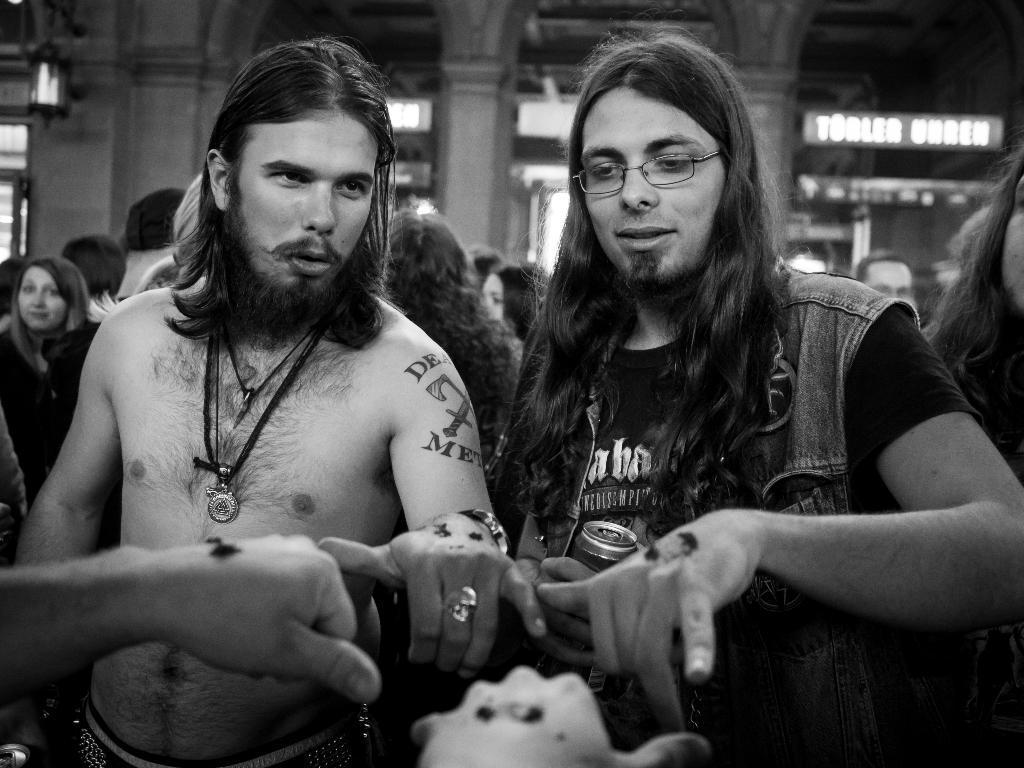In one or two sentences, can you explain what this image depicts? In this image we can see two persons are standing, he is wearing the glasses, at the back there are group of persons standing, there are pillars, there are lights, there it is in black and white. 